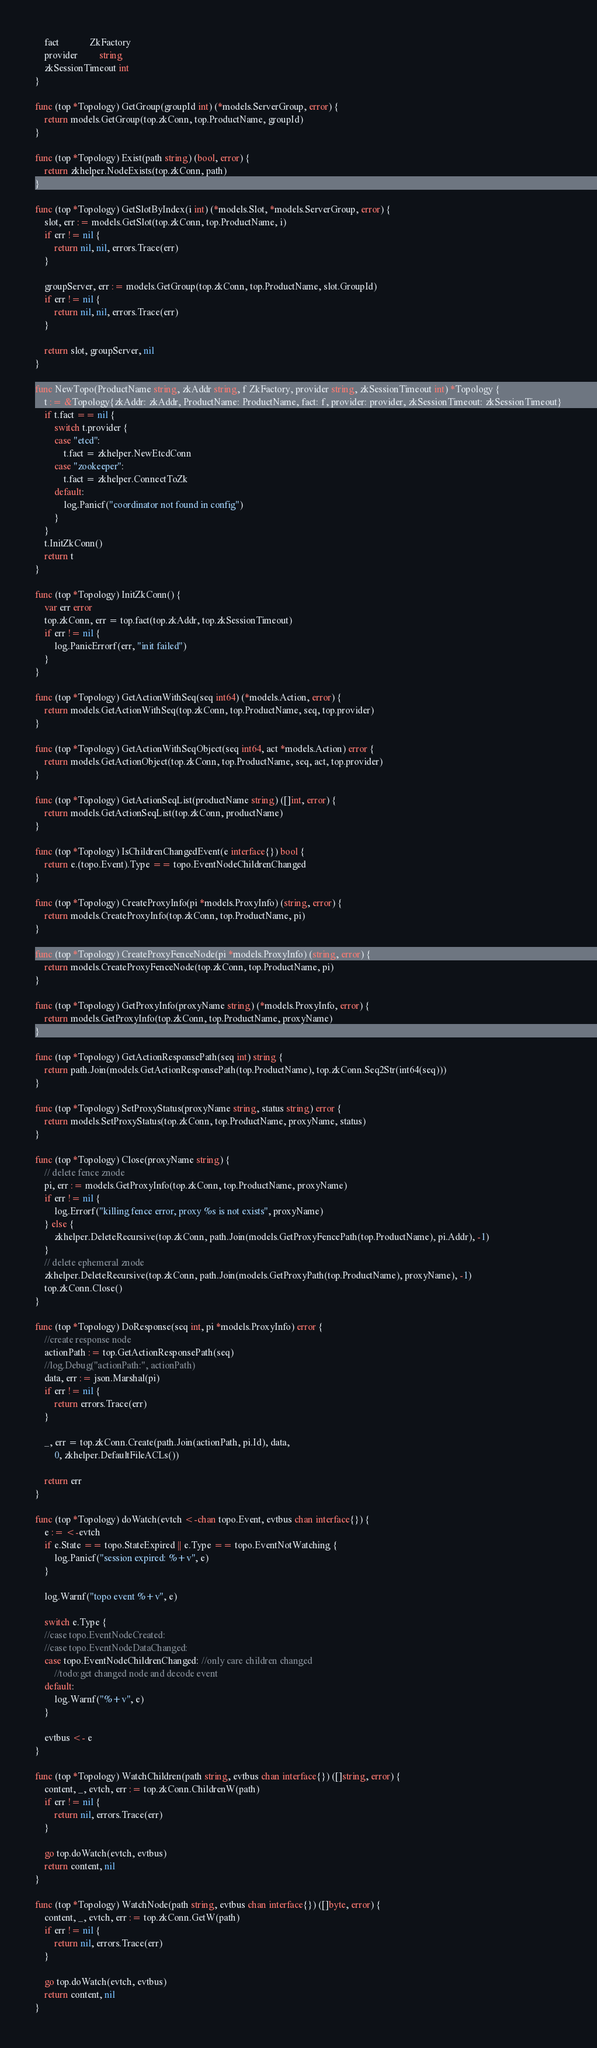<code> <loc_0><loc_0><loc_500><loc_500><_Go_>	fact             ZkFactory
	provider         string
	zkSessionTimeout int
}

func (top *Topology) GetGroup(groupId int) (*models.ServerGroup, error) {
	return models.GetGroup(top.zkConn, top.ProductName, groupId)
}

func (top *Topology) Exist(path string) (bool, error) {
	return zkhelper.NodeExists(top.zkConn, path)
}

func (top *Topology) GetSlotByIndex(i int) (*models.Slot, *models.ServerGroup, error) {
	slot, err := models.GetSlot(top.zkConn, top.ProductName, i)
	if err != nil {
		return nil, nil, errors.Trace(err)
	}

	groupServer, err := models.GetGroup(top.zkConn, top.ProductName, slot.GroupId)
	if err != nil {
		return nil, nil, errors.Trace(err)
	}

	return slot, groupServer, nil
}

func NewTopo(ProductName string, zkAddr string, f ZkFactory, provider string, zkSessionTimeout int) *Topology {
	t := &Topology{zkAddr: zkAddr, ProductName: ProductName, fact: f, provider: provider, zkSessionTimeout: zkSessionTimeout}
	if t.fact == nil {
		switch t.provider {
		case "etcd":
			t.fact = zkhelper.NewEtcdConn
		case "zookeeper":
			t.fact = zkhelper.ConnectToZk
		default:
			log.Panicf("coordinator not found in config")
		}
	}
	t.InitZkConn()
	return t
}

func (top *Topology) InitZkConn() {
	var err error
	top.zkConn, err = top.fact(top.zkAddr, top.zkSessionTimeout)
	if err != nil {
		log.PanicErrorf(err, "init failed")
	}
}

func (top *Topology) GetActionWithSeq(seq int64) (*models.Action, error) {
	return models.GetActionWithSeq(top.zkConn, top.ProductName, seq, top.provider)
}

func (top *Topology) GetActionWithSeqObject(seq int64, act *models.Action) error {
	return models.GetActionObject(top.zkConn, top.ProductName, seq, act, top.provider)
}

func (top *Topology) GetActionSeqList(productName string) ([]int, error) {
	return models.GetActionSeqList(top.zkConn, productName)
}

func (top *Topology) IsChildrenChangedEvent(e interface{}) bool {
	return e.(topo.Event).Type == topo.EventNodeChildrenChanged
}

func (top *Topology) CreateProxyInfo(pi *models.ProxyInfo) (string, error) {
	return models.CreateProxyInfo(top.zkConn, top.ProductName, pi)
}

func (top *Topology) CreateProxyFenceNode(pi *models.ProxyInfo) (string, error) {
	return models.CreateProxyFenceNode(top.zkConn, top.ProductName, pi)
}

func (top *Topology) GetProxyInfo(proxyName string) (*models.ProxyInfo, error) {
	return models.GetProxyInfo(top.zkConn, top.ProductName, proxyName)
}

func (top *Topology) GetActionResponsePath(seq int) string {
	return path.Join(models.GetActionResponsePath(top.ProductName), top.zkConn.Seq2Str(int64(seq)))
}

func (top *Topology) SetProxyStatus(proxyName string, status string) error {
	return models.SetProxyStatus(top.zkConn, top.ProductName, proxyName, status)
}

func (top *Topology) Close(proxyName string) {
	// delete fence znode
	pi, err := models.GetProxyInfo(top.zkConn, top.ProductName, proxyName)
	if err != nil {
		log.Errorf("killing fence error, proxy %s is not exists", proxyName)
	} else {
		zkhelper.DeleteRecursive(top.zkConn, path.Join(models.GetProxyFencePath(top.ProductName), pi.Addr), -1)
	}
	// delete ephemeral znode
	zkhelper.DeleteRecursive(top.zkConn, path.Join(models.GetProxyPath(top.ProductName), proxyName), -1)
	top.zkConn.Close()
}

func (top *Topology) DoResponse(seq int, pi *models.ProxyInfo) error {
	//create response node
	actionPath := top.GetActionResponsePath(seq)
	//log.Debug("actionPath:", actionPath)
	data, err := json.Marshal(pi)
	if err != nil {
		return errors.Trace(err)
	}

	_, err = top.zkConn.Create(path.Join(actionPath, pi.Id), data,
		0, zkhelper.DefaultFileACLs())

	return err
}

func (top *Topology) doWatch(evtch <-chan topo.Event, evtbus chan interface{}) {
	e := <-evtch
	if e.State == topo.StateExpired || e.Type == topo.EventNotWatching {
		log.Panicf("session expired: %+v", e)
	}

	log.Warnf("topo event %+v", e)

	switch e.Type {
	//case topo.EventNodeCreated:
	//case topo.EventNodeDataChanged:
	case topo.EventNodeChildrenChanged: //only care children changed
		//todo:get changed node and decode event
	default:
		log.Warnf("%+v", e)
	}

	evtbus <- e
}

func (top *Topology) WatchChildren(path string, evtbus chan interface{}) ([]string, error) {
	content, _, evtch, err := top.zkConn.ChildrenW(path)
	if err != nil {
		return nil, errors.Trace(err)
	}

	go top.doWatch(evtch, evtbus)
	return content, nil
}

func (top *Topology) WatchNode(path string, evtbus chan interface{}) ([]byte, error) {
	content, _, evtch, err := top.zkConn.GetW(path)
	if err != nil {
		return nil, errors.Trace(err)
	}

	go top.doWatch(evtch, evtbus)
	return content, nil
}
</code> 